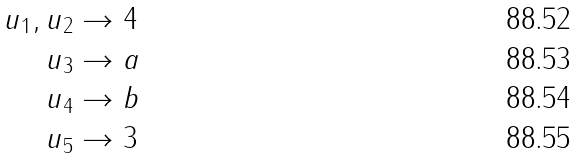<formula> <loc_0><loc_0><loc_500><loc_500>u _ { 1 } , u _ { 2 } & \to 4 \\ u _ { 3 } & \to a \\ u _ { 4 } & \to b \\ u _ { 5 } & \to 3</formula> 